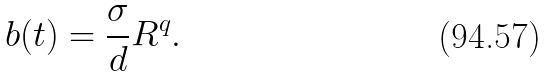<formula> <loc_0><loc_0><loc_500><loc_500>b ( t ) = \frac { \sigma } { d } R ^ { q } .</formula> 